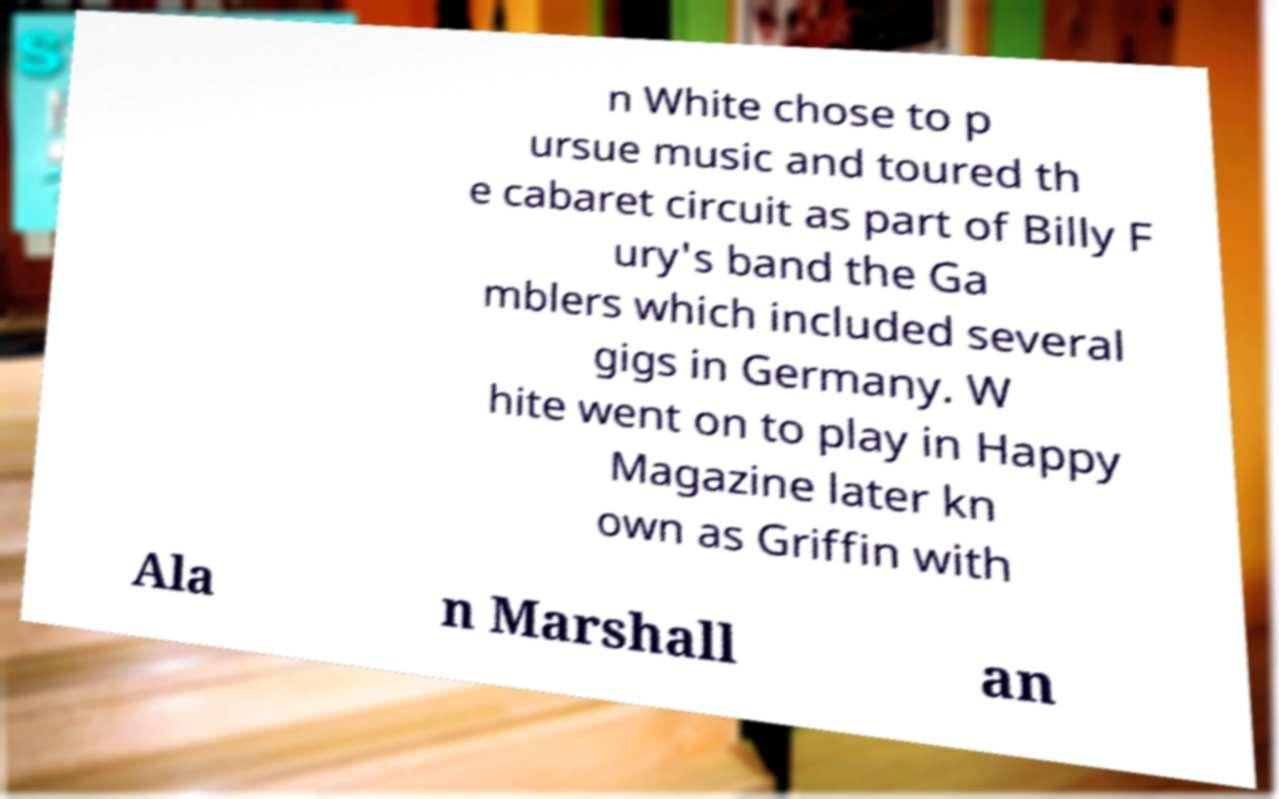Could you assist in decoding the text presented in this image and type it out clearly? n White chose to p ursue music and toured th e cabaret circuit as part of Billy F ury's band the Ga mblers which included several gigs in Germany. W hite went on to play in Happy Magazine later kn own as Griffin with Ala n Marshall an 